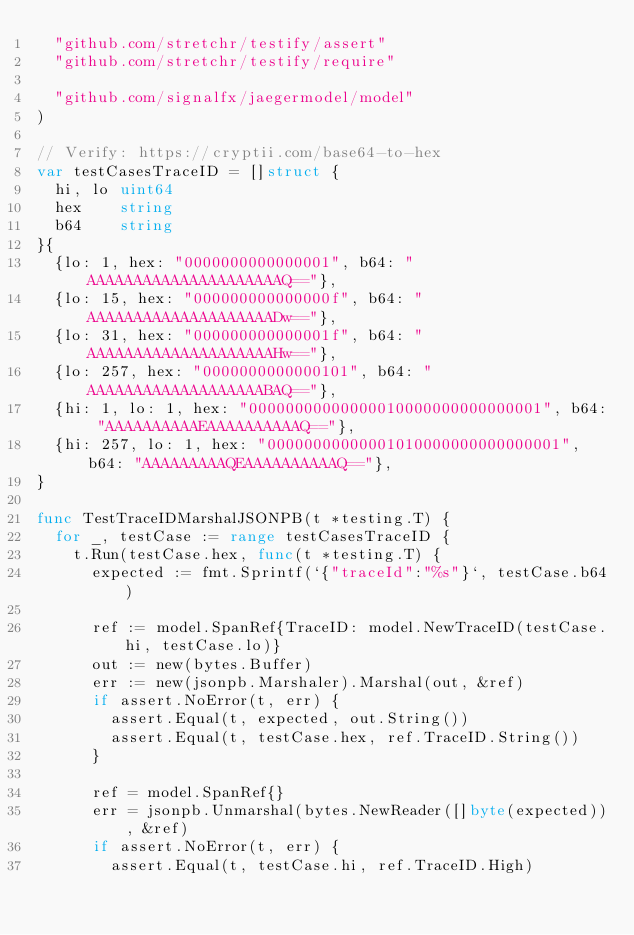Convert code to text. <code><loc_0><loc_0><loc_500><loc_500><_Go_>	"github.com/stretchr/testify/assert"
	"github.com/stretchr/testify/require"

	"github.com/signalfx/jaegermodel/model"
)

// Verify: https://cryptii.com/base64-to-hex
var testCasesTraceID = []struct {
	hi, lo uint64
	hex    string
	b64    string
}{
	{lo: 1, hex: "0000000000000001", b64: "AAAAAAAAAAAAAAAAAAAAAQ=="},
	{lo: 15, hex: "000000000000000f", b64: "AAAAAAAAAAAAAAAAAAAADw=="},
	{lo: 31, hex: "000000000000001f", b64: "AAAAAAAAAAAAAAAAAAAAHw=="},
	{lo: 257, hex: "0000000000000101", b64: "AAAAAAAAAAAAAAAAAAABAQ=="},
	{hi: 1, lo: 1, hex: "00000000000000010000000000000001", b64: "AAAAAAAAAAEAAAAAAAAAAQ=="},
	{hi: 257, lo: 1, hex: "00000000000001010000000000000001", b64: "AAAAAAAAAQEAAAAAAAAAAQ=="},
}

func TestTraceIDMarshalJSONPB(t *testing.T) {
	for _, testCase := range testCasesTraceID {
		t.Run(testCase.hex, func(t *testing.T) {
			expected := fmt.Sprintf(`{"traceId":"%s"}`, testCase.b64)

			ref := model.SpanRef{TraceID: model.NewTraceID(testCase.hi, testCase.lo)}
			out := new(bytes.Buffer)
			err := new(jsonpb.Marshaler).Marshal(out, &ref)
			if assert.NoError(t, err) {
				assert.Equal(t, expected, out.String())
				assert.Equal(t, testCase.hex, ref.TraceID.String())
			}

			ref = model.SpanRef{}
			err = jsonpb.Unmarshal(bytes.NewReader([]byte(expected)), &ref)
			if assert.NoError(t, err) {
				assert.Equal(t, testCase.hi, ref.TraceID.High)</code> 